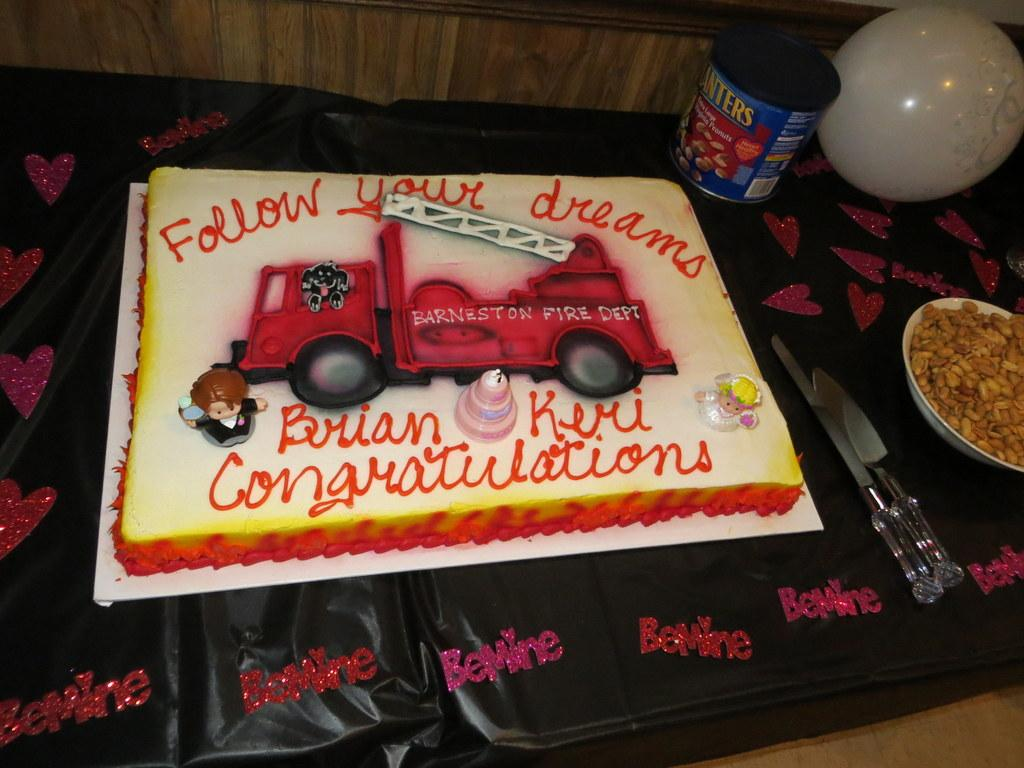What is the main food item in the image? There is a cake in the image. What type of food is in the bowl next to the cake? There are nuts in a bowl in the image. What type of container is visible in the image? There is a box in the image. What decorative item is present in the image? There is a balloon in the image. What is the color of the surface the objects are on? The surface the objects are on is black. What can be seen below the objects in the image? There is a floor visible at the bottom of the image. How does the ray swim in the basin in the image? There is no ray or basin present in the image. 